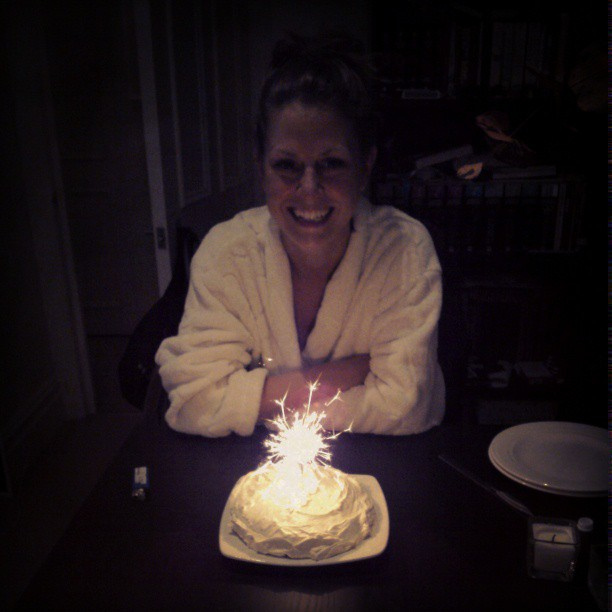<image>How old is the birthday person? It's ambiguous. The age of the birthday person could be anywhere from 25 to 50. What number of sparklers are in this cake? I don't know the exact number of sparklers in the cake. It could be one or two. What number of sparklers are in this cake? There is one sparkler in the cake. How old is the birthday person? I am not sure how old the birthday person is. It can be either 30, 40, or 38. 